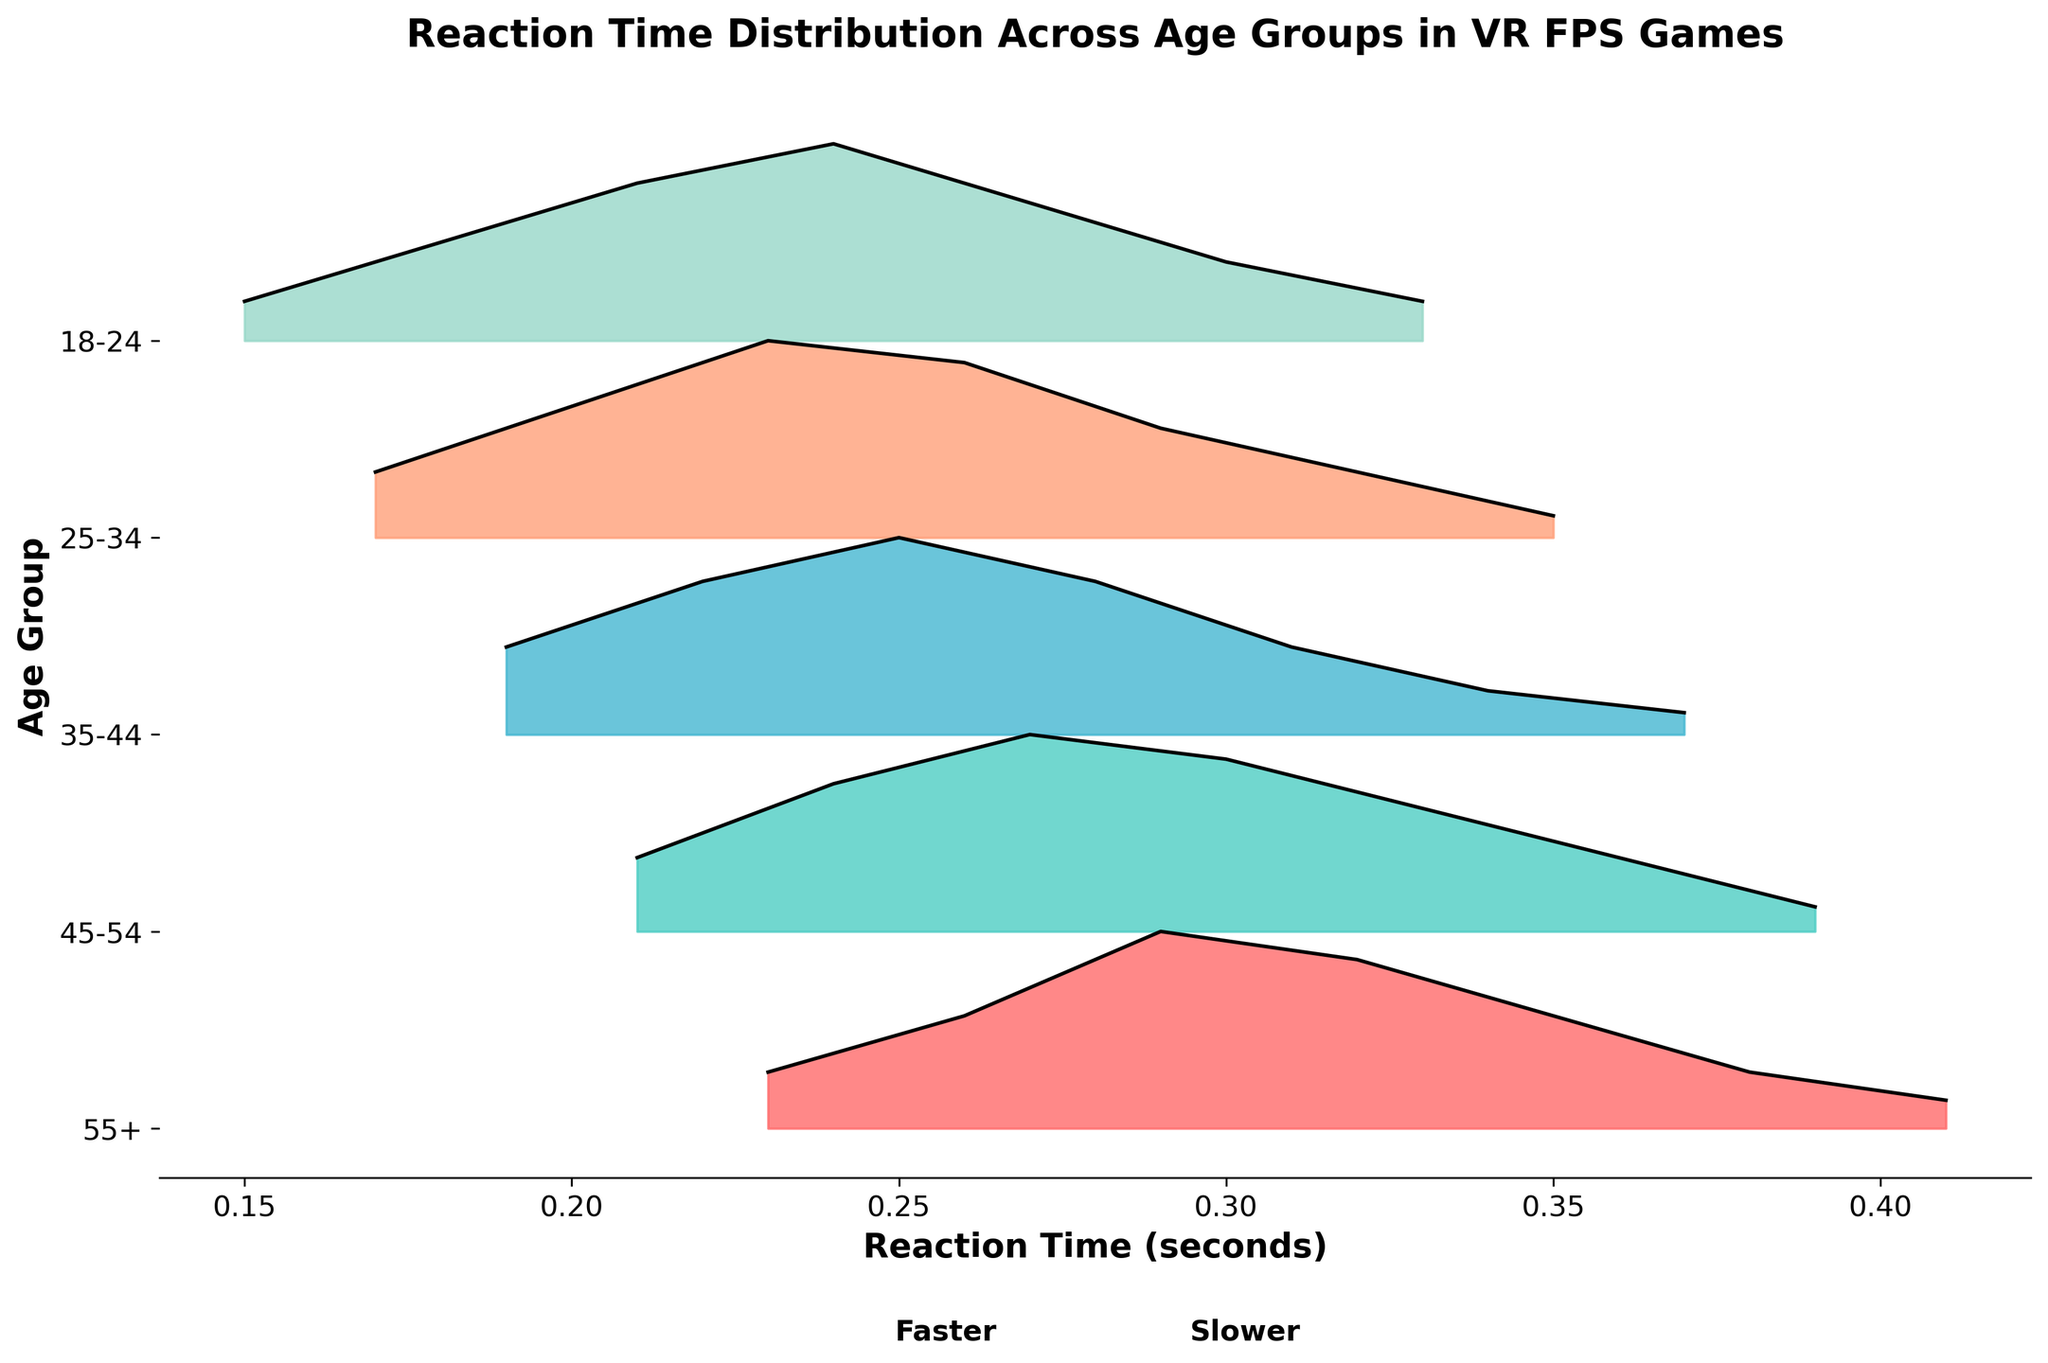What's the title of the plot? The title of the plot is located at the top and indicates the main information being conveyed.
Answer: Reaction Time Distribution Across Age Groups in VR FPS Games Which age group shows the fastest reaction times on average? The fastest reaction times correspond to the leftward spread on the plot, indicating lower reaction times. The age group 18-24's distribution spans the lowest reaction time values.
Answer: 18-24 How does the reaction time distribution shift with increasing age groups? By observing the position of the distribution peaks from bottom to top, it is clear that the peaks shift rightwards, indicating that reaction times increase with age.
Answer: It shifts towards higher reaction times Which age group has the widest spread of reaction times? The widest spread of reaction times can be identified by comparing the horizontal span of each age group's distribution. The 55+ age group shows a wider spread from about 0.23 to 0.41.
Answer: 55+ What is the reaction time range with the highest density for the 25-34 age group? By looking at the 25-34 age group's peak, the highest density covers the range around this peak. The peak is at the reaction time of 0.23 seconds.
Answer: Around 0.23 seconds How does the peak density of the 35-44 age group compare to that of the 18-24 age group? By comparing the heights of the peaks for the two age groups, the peak density for 35-44 is lower than that of 18-24, indicating that the 18-24 group has a higher density at its peak.
Answer: 35-44 is less than 18-24 Which age group has the least amount of participants with very fast reaction times (<0.20s)? By examining the leftmost sections of each age group's plot, the 45-54 and 55+ age groups hardly cover reaction times under 0.20 seconds.
Answer: 45-54 and 55+ What can you infer about reaction time variability as age increases from this plot? As the age groups increase from 18-24 to 55+, the spread of reaction times also increases, indicating more variability in reaction times in older age groups.
Answer: Increases with age How do the reaction time distributions of the 45-54 and 35-44 age groups primarily differ? By comparing the distributions, the 45-54 age group peaks at a slightly higher reaction time and has a wider distribution compared to the 35-44 group.
Answer: 45-54 peaks higher and is wider 